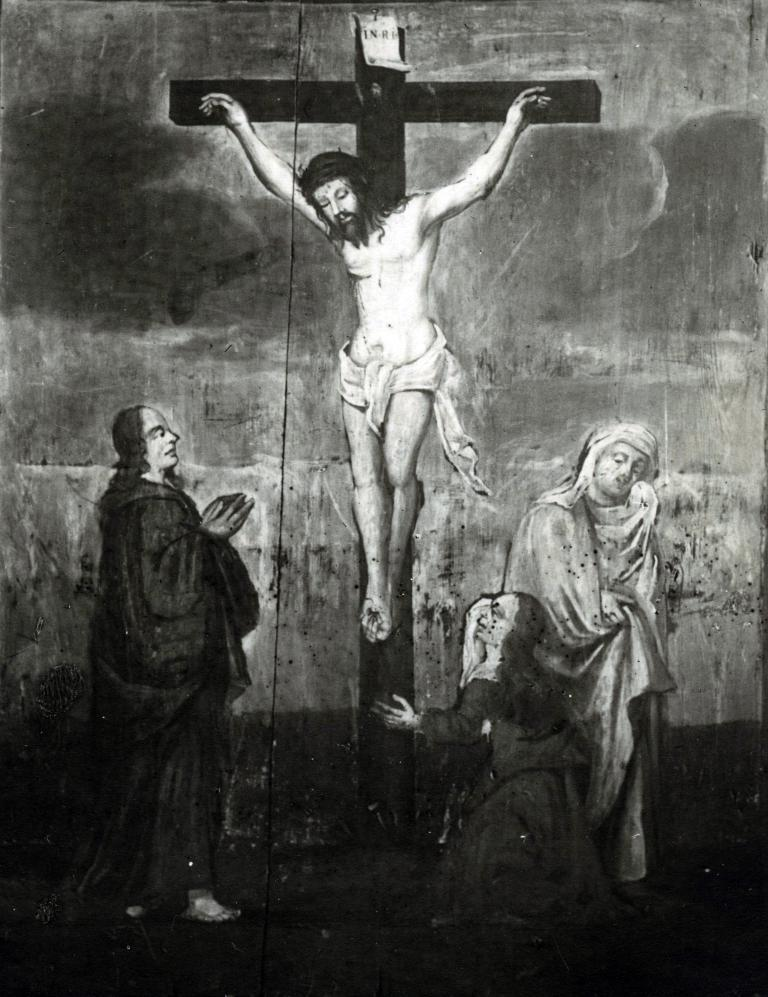What is the main subject of the sketch in the image? The main subject of the sketch in the image is Jesus. Are there any other figures in the sketch? Yes, there are other persons in the sketch. What is the color scheme of the image? The image is black and white in color. What type of island can be seen in the background of the sketch? There is no island present in the sketch; it is a black and white drawing of Jesus and other persons. What kind of loaf is being used to create the sketch? The sketch is not created with a loaf; it is a drawing, likely made with a pencil or pen. 